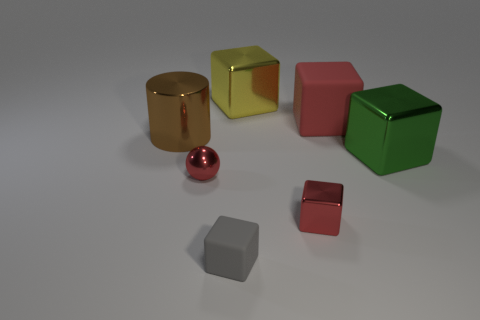Is there any pattern or symmetry in the arrangement of the objects? The objects are arranged without any obvious pattern or symmetry. They are placed at varying distances from each other with differences in orientation, resulting in a random, asymmetrical layout. 